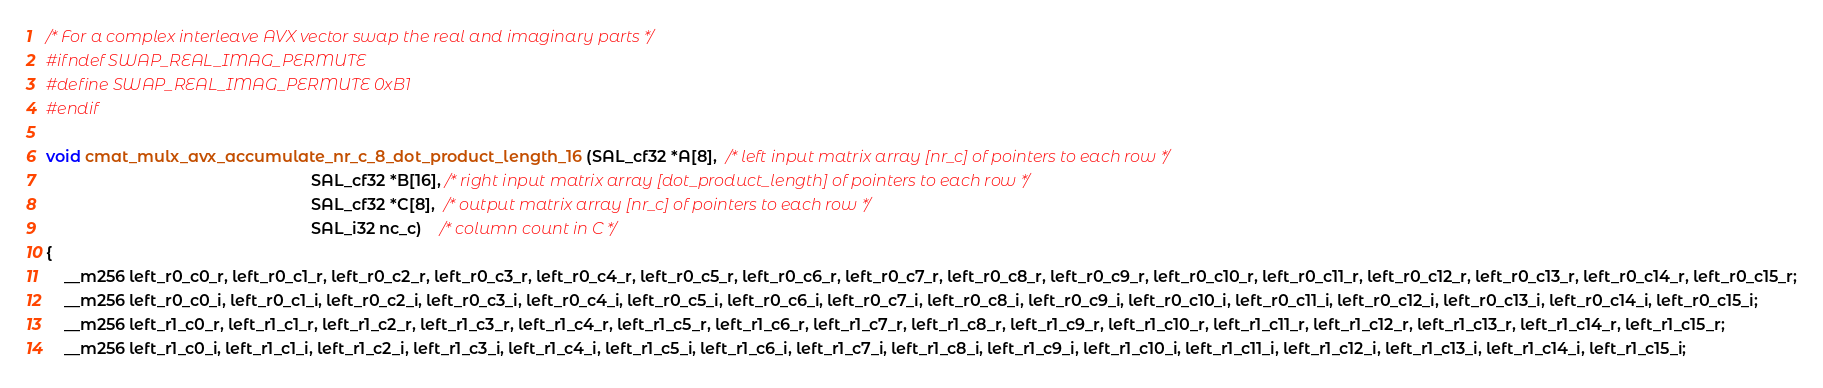Convert code to text. <code><loc_0><loc_0><loc_500><loc_500><_C_>/* For a complex interleave AVX vector swap the real and imaginary parts */
#ifndef SWAP_REAL_IMAG_PERMUTE
#define SWAP_REAL_IMAG_PERMUTE 0xB1
#endif

void cmat_mulx_avx_accumulate_nr_c_8_dot_product_length_16 (SAL_cf32 *A[8],  /* left input matrix array [nr_c] of pointers to each row */
                                                            SAL_cf32 *B[16], /* right input matrix array [dot_product_length] of pointers to each row */
                                                            SAL_cf32 *C[8],  /* output matrix array [nr_c] of pointers to each row */
                                                            SAL_i32 nc_c)    /* column count in C */
{
    __m256 left_r0_c0_r, left_r0_c1_r, left_r0_c2_r, left_r0_c3_r, left_r0_c4_r, left_r0_c5_r, left_r0_c6_r, left_r0_c7_r, left_r0_c8_r, left_r0_c9_r, left_r0_c10_r, left_r0_c11_r, left_r0_c12_r, left_r0_c13_r, left_r0_c14_r, left_r0_c15_r;
    __m256 left_r0_c0_i, left_r0_c1_i, left_r0_c2_i, left_r0_c3_i, left_r0_c4_i, left_r0_c5_i, left_r0_c6_i, left_r0_c7_i, left_r0_c8_i, left_r0_c9_i, left_r0_c10_i, left_r0_c11_i, left_r0_c12_i, left_r0_c13_i, left_r0_c14_i, left_r0_c15_i;
    __m256 left_r1_c0_r, left_r1_c1_r, left_r1_c2_r, left_r1_c3_r, left_r1_c4_r, left_r1_c5_r, left_r1_c6_r, left_r1_c7_r, left_r1_c8_r, left_r1_c9_r, left_r1_c10_r, left_r1_c11_r, left_r1_c12_r, left_r1_c13_r, left_r1_c14_r, left_r1_c15_r;
    __m256 left_r1_c0_i, left_r1_c1_i, left_r1_c2_i, left_r1_c3_i, left_r1_c4_i, left_r1_c5_i, left_r1_c6_i, left_r1_c7_i, left_r1_c8_i, left_r1_c9_i, left_r1_c10_i, left_r1_c11_i, left_r1_c12_i, left_r1_c13_i, left_r1_c14_i, left_r1_c15_i;</code> 